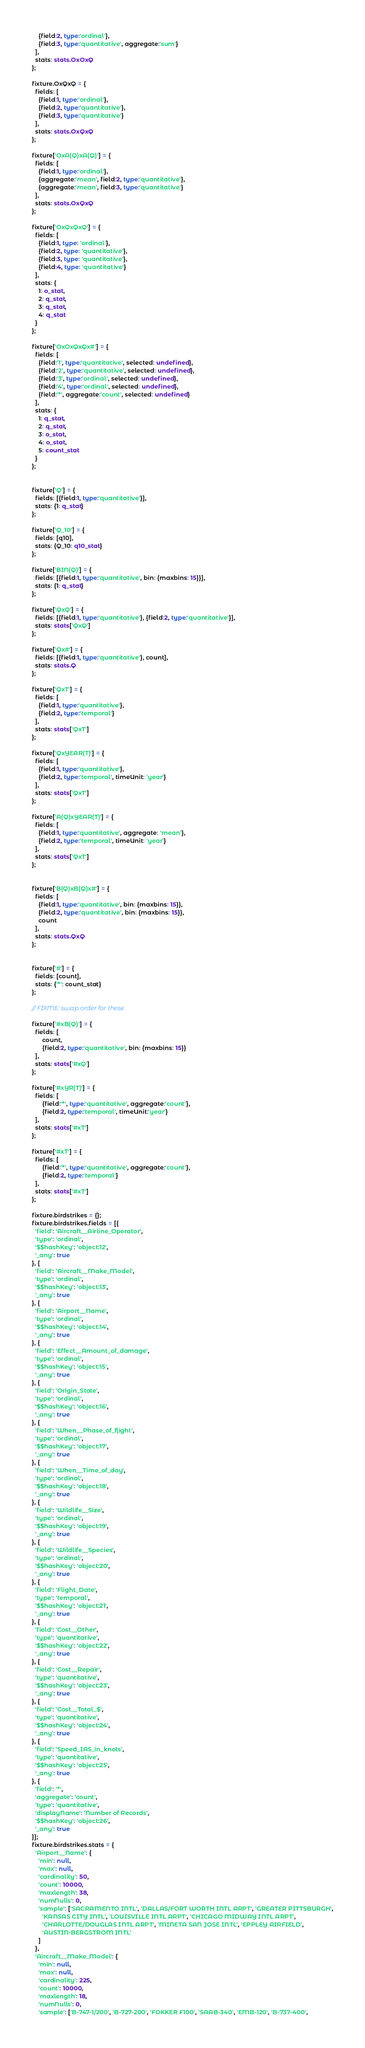<code> <loc_0><loc_0><loc_500><loc_500><_TypeScript_>    {field:2, type:'ordinal'},
    {field:3, type:'quantitative', aggregate:'sum'}
  ],
  stats: stats.OxOxQ
};

fixture.OxQxQ = {
  fields: [
    {field:1, type:'ordinal'},
    {field:2, type:'quantitative'},
    {field:3, type:'quantitative'}
  ],
  stats: stats.OxQxQ
};

fixture['OxA(Q)xA(Q)'] = {
  fields: [
    {field:1, type:'ordinal'},
    {aggregate:'mean', field:2, type:'quantitative'},
    {aggregate:'mean', field:3, type:'quantitative'}
  ],
  stats: stats.OxQxQ
};

fixture['OxQxQxQ'] = {
  fields: [
    {field:1, type: 'ordinal'},
    {field:2, type: 'quantitative'},
    {field:3, type: 'quantitative'},
    {field:4, type: 'quantitative'}
  ],
  stats: {
    1: o_stat,
    2: q_stat,
    3: q_stat,
    4: q_stat
  }
};

fixture['OxOxQxQx#'] = {
  fields: [
    {field:'1', type:'quantitative', selected: undefined},
    {field:'2', type:'quantitative', selected: undefined},
    {field:'3', type:'ordinal', selected: undefined},
    {field:'4', type:'ordinal', selected: undefined},
    {field:'*', aggregate:'count', selected: undefined}
  ],
  stats: {
    1: q_stat,
    2: q_stat,
    3: o_stat,
    4: o_stat,
    5: count_stat
  }
};


fixture['Q'] = {
  fields: [{field:1, type:'quantitative'}],
  stats: {1: q_stat}
};

fixture['Q_10'] = {
  fields: [q10],
  stats: {Q_10: q10_stat}
};

fixture['BIN(Q)'] = {
  fields: [{field:1, type:'quantitative', bin: {maxbins: 15}}],
  stats: {1: q_stat}
};

fixture['QxQ'] = {
  fields: [{field:1, type:'quantitative'}, {field:2, type:'quantitative'}],
  stats: stats['QxQ']
};

fixture['Qx#'] = {
  fields: [{field:1, type:'quantitative'}, count],
  stats: stats.Q
};

fixture['QxT'] = {
  fields: [
    {field:1, type:'quantitative'},
    {field:2, type:'temporal'}
  ],
  stats: stats['QxT']
};

fixture['QxYEAR(T)'] = {
  fields: [
    {field:1, type:'quantitative'},
    {field:2, type:'temporal', timeUnit: 'year'}
  ],
  stats: stats['QxT']
};

fixture['A(Q)xYEAR(T)'] = {
  fields: [
    {field:1, type:'quantitative', aggregate: 'mean'},
    {field:2, type:'temporal', timeUnit: 'year'}
  ],
  stats: stats['QxT']
};


fixture['B(Q)xB(Q)x#'] = {
  fields: [
    {field:1, type:'quantitative', bin: {maxbins: 15}},
    {field:2, type:'quantitative', bin: {maxbins: 15}},
    count
  ],
  stats: stats.QxQ
};


fixture['#'] = {
  fields: [count],
  stats: {'*': count_stat}
};

// FIXME: swap order for these

fixture['#xB(Q)'] = {
  fields: [
      count,
      {field:2, type:'quantitative', bin: {maxbins: 15}}
  ],
  stats: stats['#xQ']
};

fixture['#xYR(T)'] = {
  fields: [
      {field:'*', type:'quantitative', aggregate:'count'},
      {field:2, type:'temporal', timeUnit:'year'}
  ],
  stats: stats['#xT']
};

fixture['#xT'] = {
  fields: [
      {field:'*', type:'quantitative', aggregate:'count'},
      {field:2, type:'temporal'}
  ],
  stats: stats['#xT']
};

fixture.birdstrikes = {};
fixture.birdstrikes.fields = [{
  'field': 'Aircraft__Airline_Operator',
  'type': 'ordinal',
  '$$hashKey': 'object:12',
  '_any': true
}, {
  'field': 'Aircraft__Make_Model',
  'type': 'ordinal',
  '$$hashKey': 'object:13',
  '_any': true
}, {
  'field': 'Airport__Name',
  'type': 'ordinal',
  '$$hashKey': 'object:14',
  '_any': true
}, {
  'field': 'Effect__Amount_of_damage',
  'type': 'ordinal',
  '$$hashKey': 'object:15',
  '_any': true
}, {
  'field': 'Origin_State',
  'type': 'ordinal',
  '$$hashKey': 'object:16',
  '_any': true
}, {
  'field': 'When__Phase_of_flight',
  'type': 'ordinal',
  '$$hashKey': 'object:17',
  '_any': true
}, {
  'field': 'When__Time_of_day',
  'type': 'ordinal',
  '$$hashKey': 'object:18',
  '_any': true
}, {
  'field': 'Wildlife__Size',
  'type': 'ordinal',
  '$$hashKey': 'object:19',
  '_any': true
}, {
  'field': 'Wildlife__Species',
  'type': 'ordinal',
  '$$hashKey': 'object:20',
  '_any': true
}, {
  'field': 'Flight_Date',
  'type': 'temporal',
  '$$hashKey': 'object:21',
  '_any': true
}, {
  'field': 'Cost__Other',
  'type': 'quantitative',
  '$$hashKey': 'object:22',
  '_any': true
}, {
  'field': 'Cost__Repair',
  'type': 'quantitative',
  '$$hashKey': 'object:23',
  '_any': true
}, {
  'field': 'Cost__Total_$',
  'type': 'quantitative',
  '$$hashKey': 'object:24',
  '_any': true
}, {
  'field': 'Speed_IAS_in_knots',
  'type': 'quantitative',
  '$$hashKey': 'object:25',
  '_any': true
}, {
  'field': '*',
  'aggregate': 'count',
  'type': 'quantitative',
  'displayName': 'Number of Records',
  '$$hashKey': 'object:26',
  '_any': true
}];
fixture.birdstrikes.stats = {
  'Airport__Name': {
    'min': null,
    'max': null,
    'cardinality': 50,
    'count': 10000,
    'maxlength': 38,
    'numNulls': 0,
    'sample': ['SACRAMENTO INTL', 'DALLAS/FORT WORTH INTL ARPT', 'GREATER PITTSBURGH',
      'KANSAS CITY INTL', 'LOUISVILLE INTL ARPT', 'CHICAGO MIDWAY INTL ARPT',
      'CHARLOTTE/DOUGLAS INTL ARPT', 'MINETA SAN JOSE INTL', 'EPPLEY AIRFIELD',
      'AUSTIN-BERGSTROM INTL'
    ]
  },
  'Aircraft__Make_Model': {
    'min': null,
    'max': null,
    'cardinality': 225,
    'count': 10000,
    'maxlength': 18,
    'numNulls': 0,
    'sample': ['B-747-1/200', 'B-727-200', 'FOKKER F100', 'SAAB-340', 'EMB-120', 'B-737-400',</code> 